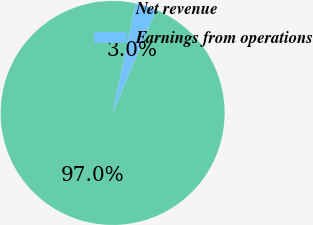<chart> <loc_0><loc_0><loc_500><loc_500><pie_chart><fcel>Net revenue<fcel>Earnings from operations<nl><fcel>96.97%<fcel>3.03%<nl></chart> 